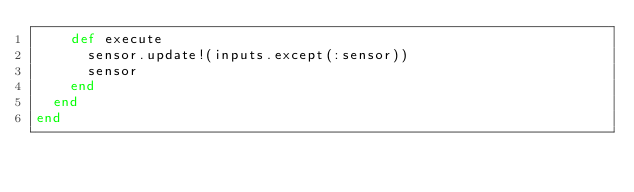Convert code to text. <code><loc_0><loc_0><loc_500><loc_500><_Ruby_>    def execute
      sensor.update!(inputs.except(:sensor))
      sensor
    end
  end
end
</code> 